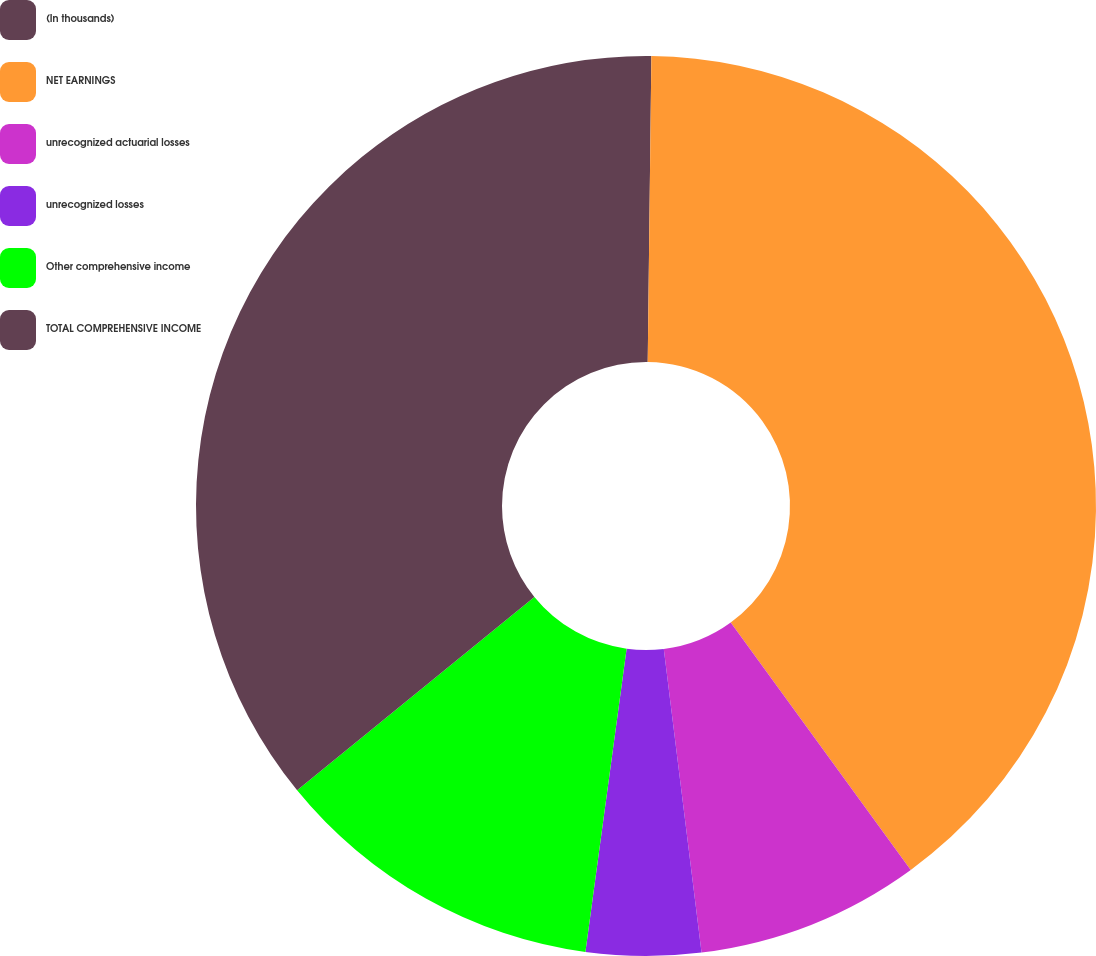Convert chart to OTSL. <chart><loc_0><loc_0><loc_500><loc_500><pie_chart><fcel>(In thousands)<fcel>NET EARNINGS<fcel>unrecognized actuarial losses<fcel>unrecognized losses<fcel>Other comprehensive income<fcel>TOTAL COMPREHENSIVE INCOME<nl><fcel>0.19%<fcel>39.8%<fcel>8.04%<fcel>4.12%<fcel>11.97%<fcel>35.88%<nl></chart> 